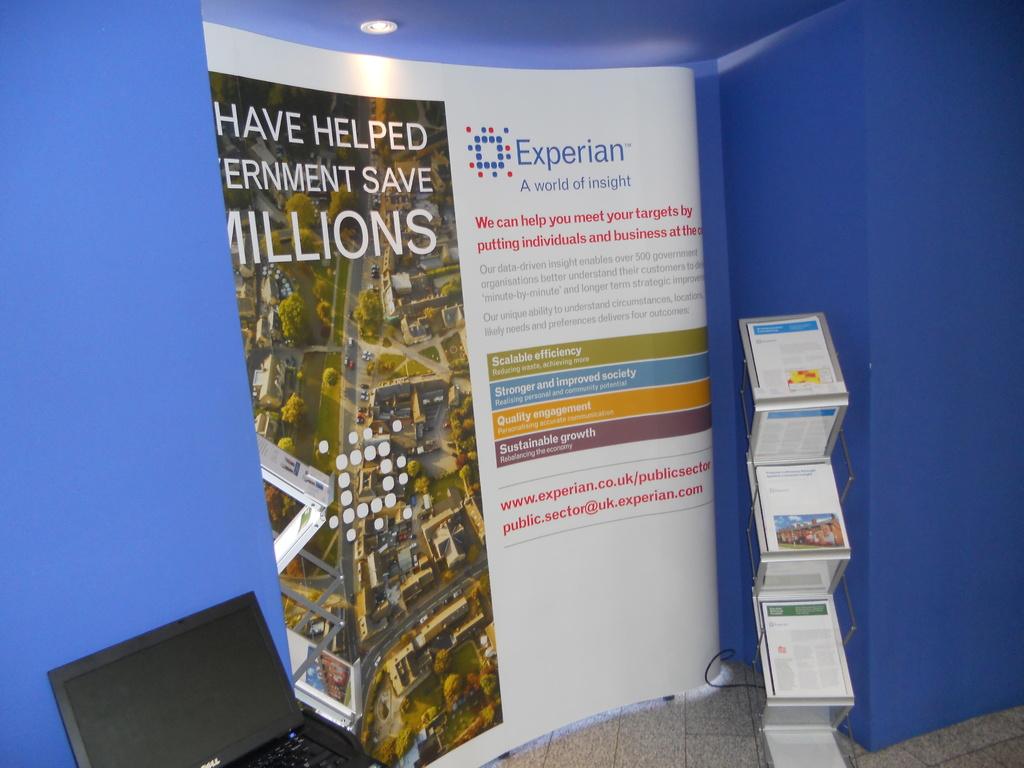What is the ad used for?
Keep it short and to the point. Experian. What company is the poster for?
Your response must be concise. Experian. 